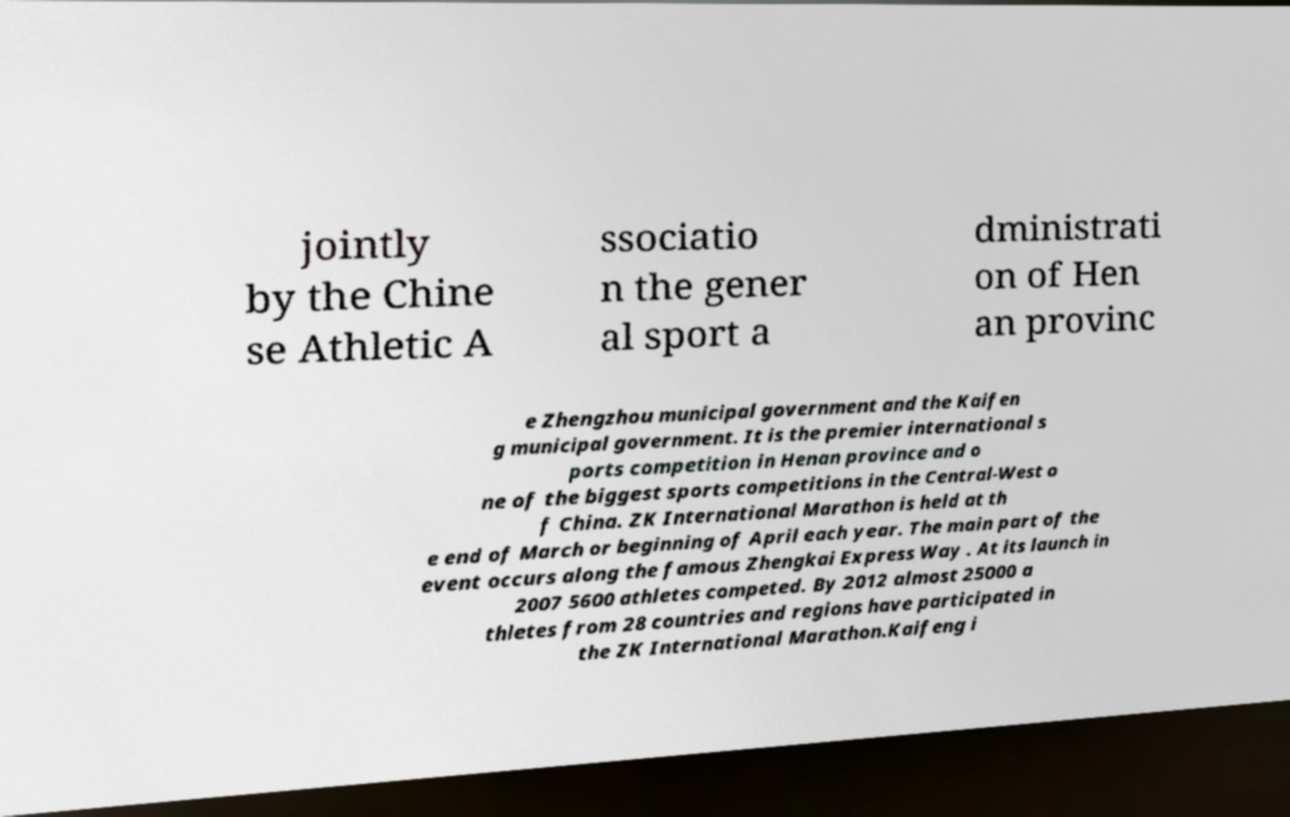I need the written content from this picture converted into text. Can you do that? jointly by the Chine se Athletic A ssociatio n the gener al sport a dministrati on of Hen an provinc e Zhengzhou municipal government and the Kaifen g municipal government. It is the premier international s ports competition in Henan province and o ne of the biggest sports competitions in the Central-West o f China. ZK International Marathon is held at th e end of March or beginning of April each year. The main part of the event occurs along the famous Zhengkai Express Way . At its launch in 2007 5600 athletes competed. By 2012 almost 25000 a thletes from 28 countries and regions have participated in the ZK International Marathon.Kaifeng i 